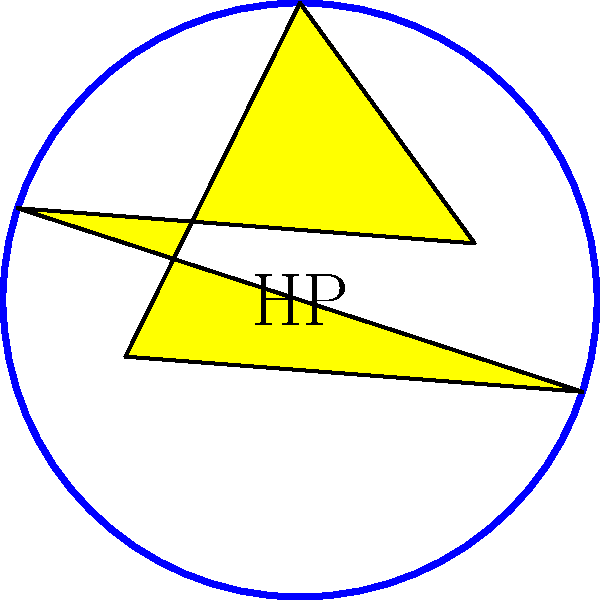Your store's logo consists of a circular border with a five-pointed star inside and the letters "HP" at the center. How many rotational symmetries does this logo have? To determine the number of rotational symmetries, we need to consider the following steps:

1. Analyze the components of the logo:
   a. Circular border: Has infinite rotational symmetry
   b. Five-pointed star: Has 5-fold rotational symmetry
   c. Letters "HP": Has no rotational symmetry (only 1-fold, i.e., 360°)

2. The overall rotational symmetry of the logo is determined by the component with the least rotational symmetry.

3. In this case, the letters "HP" have the least rotational symmetry, allowing only for a full 360° rotation.

4. Therefore, the logo has only one rotational symmetry: the identity rotation (360° or 0°).

The rotational symmetry group of this logo is isomorphic to the cyclic group $C_1$, which contains only the identity element.
Answer: 1 